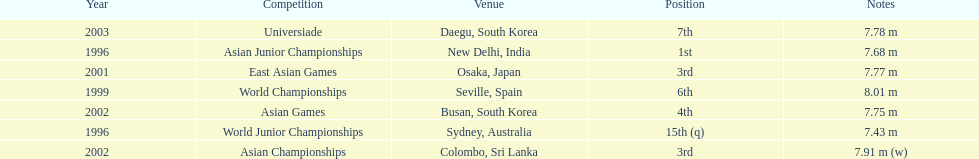What was the venue when he placed first? New Delhi, India. 